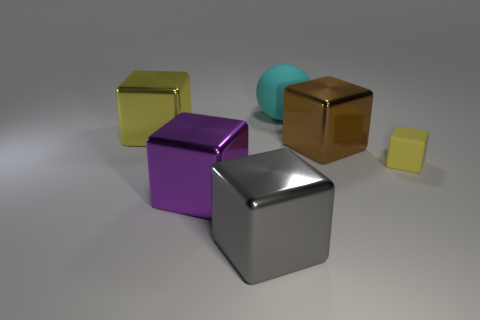Subtract 2 blocks. How many blocks are left? 3 Subtract all cyan cubes. Subtract all purple cylinders. How many cubes are left? 5 Add 2 big shiny things. How many objects exist? 8 Subtract all cubes. How many objects are left? 1 Add 6 big brown shiny cubes. How many big brown shiny cubes are left? 7 Add 3 large metal cubes. How many large metal cubes exist? 7 Subtract 0 purple cylinders. How many objects are left? 6 Subtract all large cyan matte spheres. Subtract all tiny blocks. How many objects are left? 4 